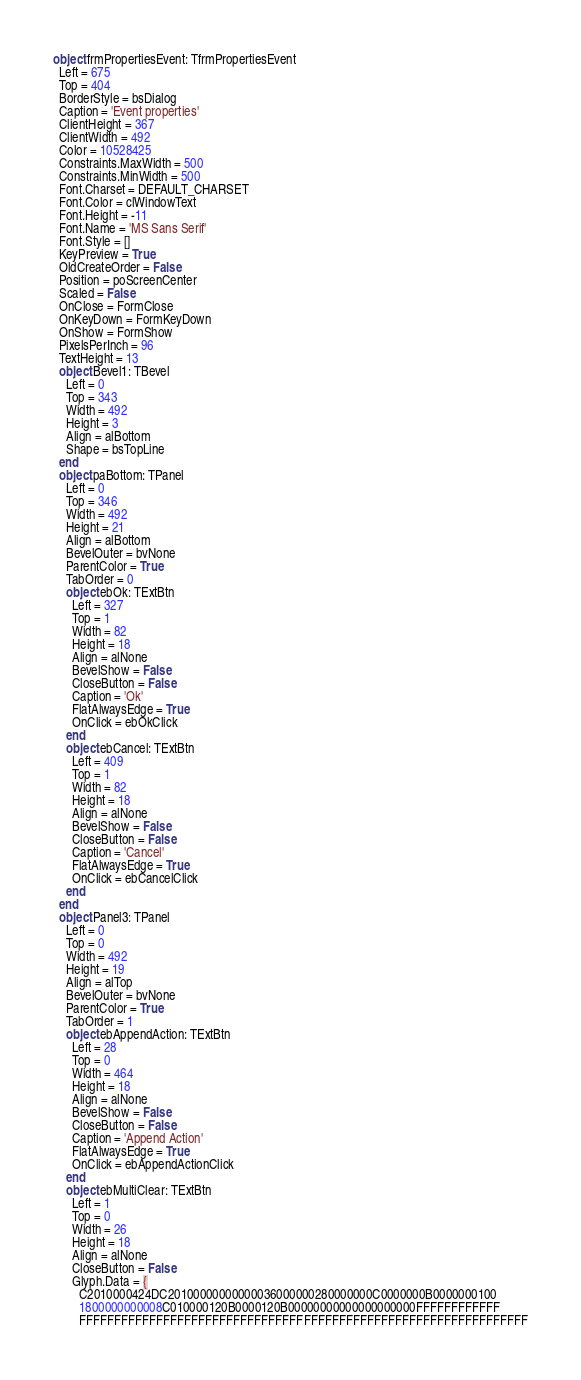<code> <loc_0><loc_0><loc_500><loc_500><_Pascal_>object frmPropertiesEvent: TfrmPropertiesEvent
  Left = 675
  Top = 404
  BorderStyle = bsDialog
  Caption = 'Event properties'
  ClientHeight = 367
  ClientWidth = 492
  Color = 10528425
  Constraints.MaxWidth = 500
  Constraints.MinWidth = 500
  Font.Charset = DEFAULT_CHARSET
  Font.Color = clWindowText
  Font.Height = -11
  Font.Name = 'MS Sans Serif'
  Font.Style = []
  KeyPreview = True
  OldCreateOrder = False
  Position = poScreenCenter
  Scaled = False
  OnClose = FormClose
  OnKeyDown = FormKeyDown
  OnShow = FormShow
  PixelsPerInch = 96
  TextHeight = 13
  object Bevel1: TBevel
    Left = 0
    Top = 343
    Width = 492
    Height = 3
    Align = alBottom
    Shape = bsTopLine
  end
  object paBottom: TPanel
    Left = 0
    Top = 346
    Width = 492
    Height = 21
    Align = alBottom
    BevelOuter = bvNone
    ParentColor = True
    TabOrder = 0
    object ebOk: TExtBtn
      Left = 327
      Top = 1
      Width = 82
      Height = 18
      Align = alNone
      BevelShow = False
      CloseButton = False
      Caption = 'Ok'
      FlatAlwaysEdge = True
      OnClick = ebOkClick
    end
    object ebCancel: TExtBtn
      Left = 409
      Top = 1
      Width = 82
      Height = 18
      Align = alNone
      BevelShow = False
      CloseButton = False
      Caption = 'Cancel'
      FlatAlwaysEdge = True
      OnClick = ebCancelClick
    end
  end
  object Panel3: TPanel
    Left = 0
    Top = 0
    Width = 492
    Height = 19
    Align = alTop
    BevelOuter = bvNone
    ParentColor = True
    TabOrder = 1
    object ebAppendAction: TExtBtn
      Left = 28
      Top = 0
      Width = 464
      Height = 18
      Align = alNone
      BevelShow = False
      CloseButton = False
      Caption = 'Append Action'
      FlatAlwaysEdge = True
      OnClick = ebAppendActionClick
    end
    object ebMultiClear: TExtBtn
      Left = 1
      Top = 0
      Width = 26
      Height = 18
      Align = alNone
      CloseButton = False
      Glyph.Data = {
        C2010000424DC20100000000000036000000280000000C0000000B0000000100
        1800000000008C010000120B0000120B00000000000000000000FFFFFFFFFFFF
        FFFFFFFFFFFFFFFFFFFFFFFFFFFFFFFFFFFFFFFFFFFFFFFFFFFFFFFFFFFFFFFF</code> 